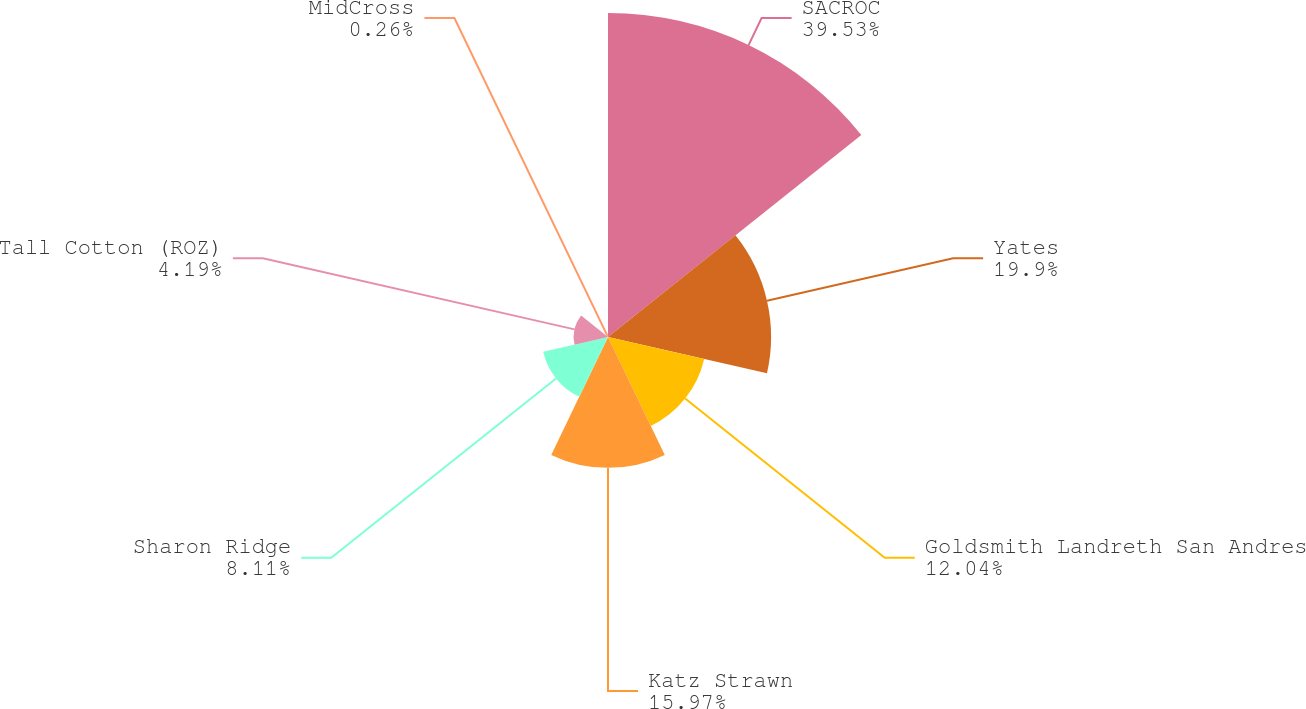<chart> <loc_0><loc_0><loc_500><loc_500><pie_chart><fcel>SACROC<fcel>Yates<fcel>Goldsmith Landreth San Andres<fcel>Katz Strawn<fcel>Sharon Ridge<fcel>Tall Cotton (ROZ)<fcel>MidCross<nl><fcel>39.54%<fcel>19.9%<fcel>12.04%<fcel>15.97%<fcel>8.11%<fcel>4.19%<fcel>0.26%<nl></chart> 